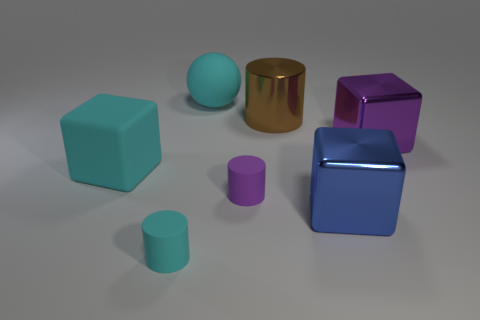Add 2 yellow things. How many objects exist? 9 Subtract all big cylinders. How many cylinders are left? 2 Subtract all cylinders. How many objects are left? 4 Subtract all purple cylinders. How many cylinders are left? 2 Subtract all large cyan cubes. Subtract all big cyan matte things. How many objects are left? 4 Add 5 large blocks. How many large blocks are left? 8 Add 7 large cubes. How many large cubes exist? 10 Subtract 0 green cubes. How many objects are left? 7 Subtract all red blocks. Subtract all red spheres. How many blocks are left? 3 Subtract all gray cylinders. How many blue blocks are left? 1 